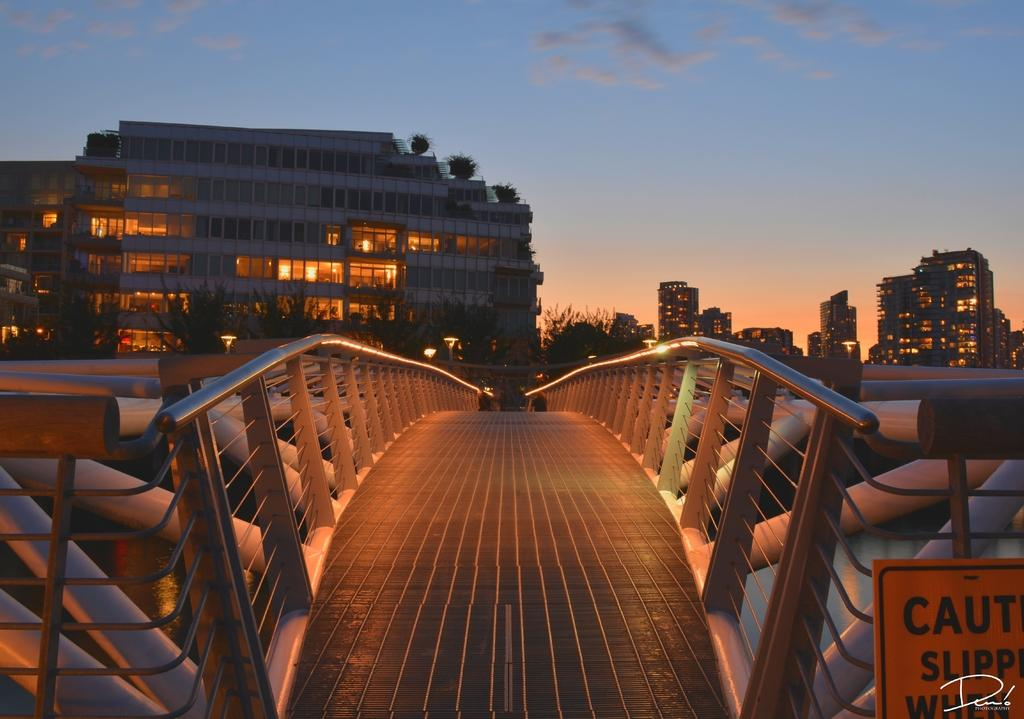Provide a one-sentence caption for the provided image. a bridge with a sign in front of it that says caution and slippery. 